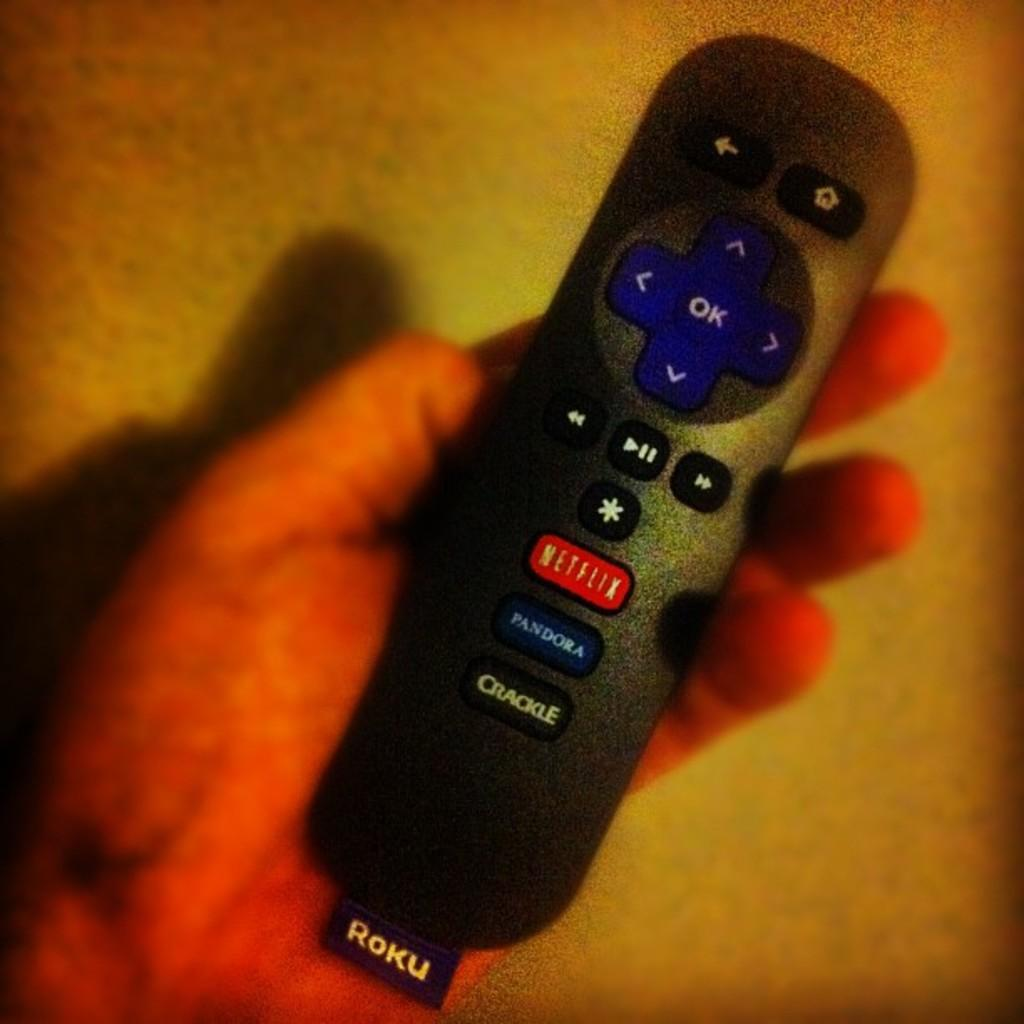<image>
Provide a brief description of the given image. A small Roku remote being held in someone's hand. 